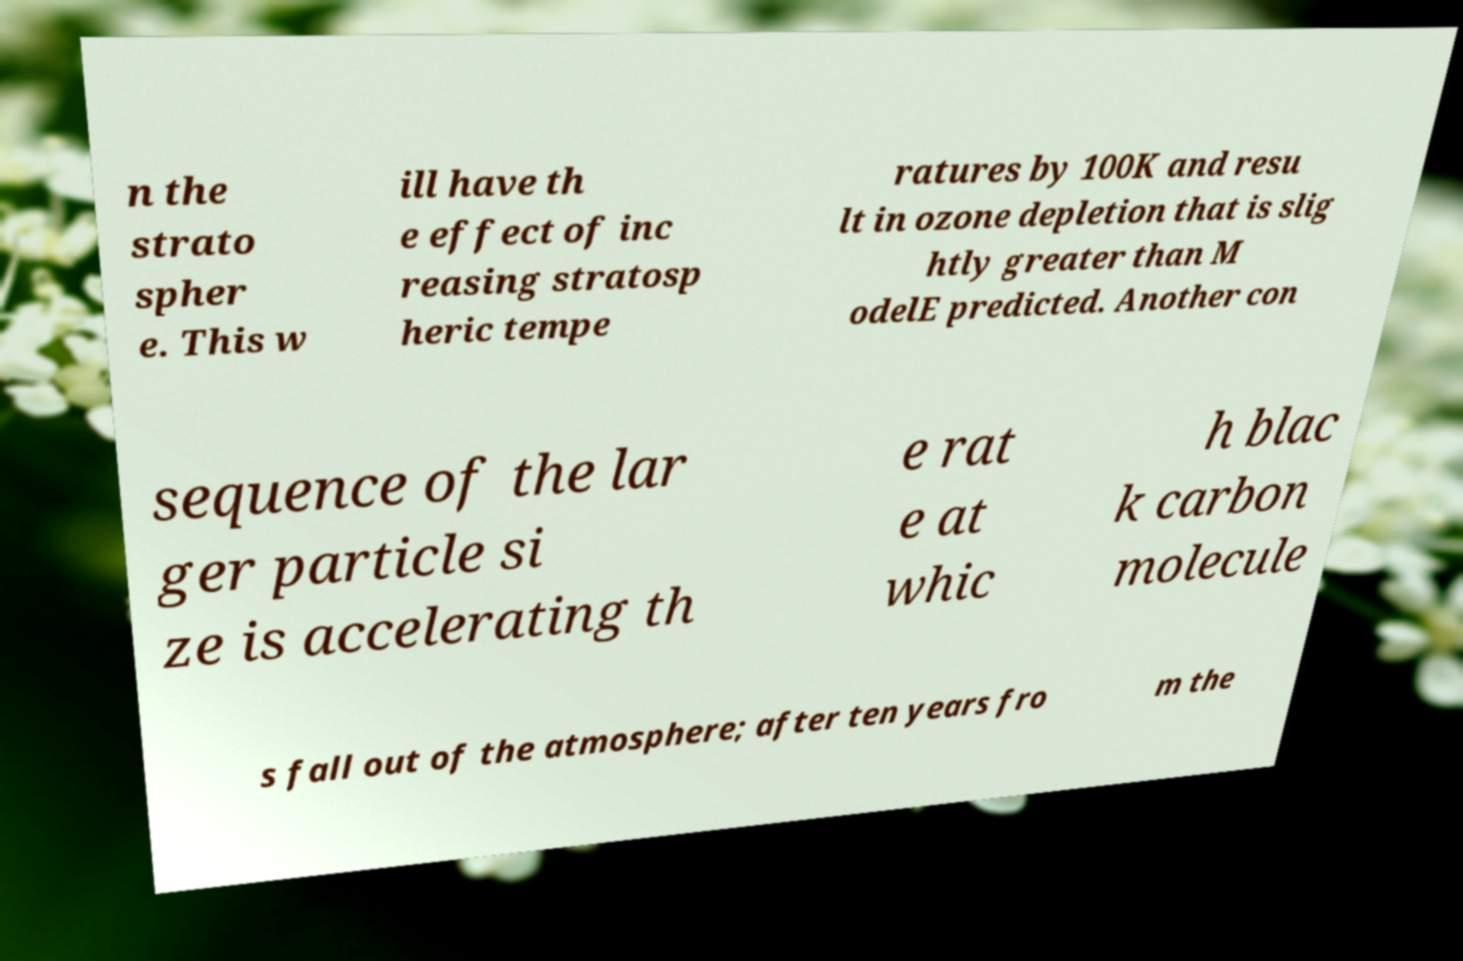Could you assist in decoding the text presented in this image and type it out clearly? n the strato spher e. This w ill have th e effect of inc reasing stratosp heric tempe ratures by 100K and resu lt in ozone depletion that is slig htly greater than M odelE predicted. Another con sequence of the lar ger particle si ze is accelerating th e rat e at whic h blac k carbon molecule s fall out of the atmosphere; after ten years fro m the 